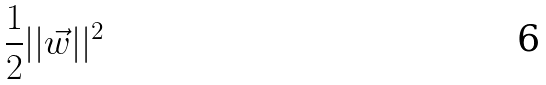Convert formula to latex. <formula><loc_0><loc_0><loc_500><loc_500>\frac { 1 } { 2 } | | \vec { w } | | ^ { 2 }</formula> 